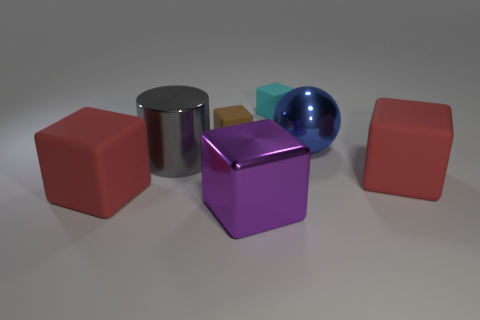Subtract all cyan cubes. How many cubes are left? 4 Subtract all cyan matte blocks. How many blocks are left? 4 Subtract 2 cubes. How many cubes are left? 3 Subtract all yellow blocks. Subtract all yellow balls. How many blocks are left? 5 Add 1 red rubber things. How many objects exist? 8 Subtract all cubes. How many objects are left? 2 Add 2 large gray cylinders. How many large gray cylinders are left? 3 Add 1 purple blocks. How many purple blocks exist? 2 Subtract 0 brown cylinders. How many objects are left? 7 Subtract all large green metal cylinders. Subtract all tiny brown rubber cubes. How many objects are left? 6 